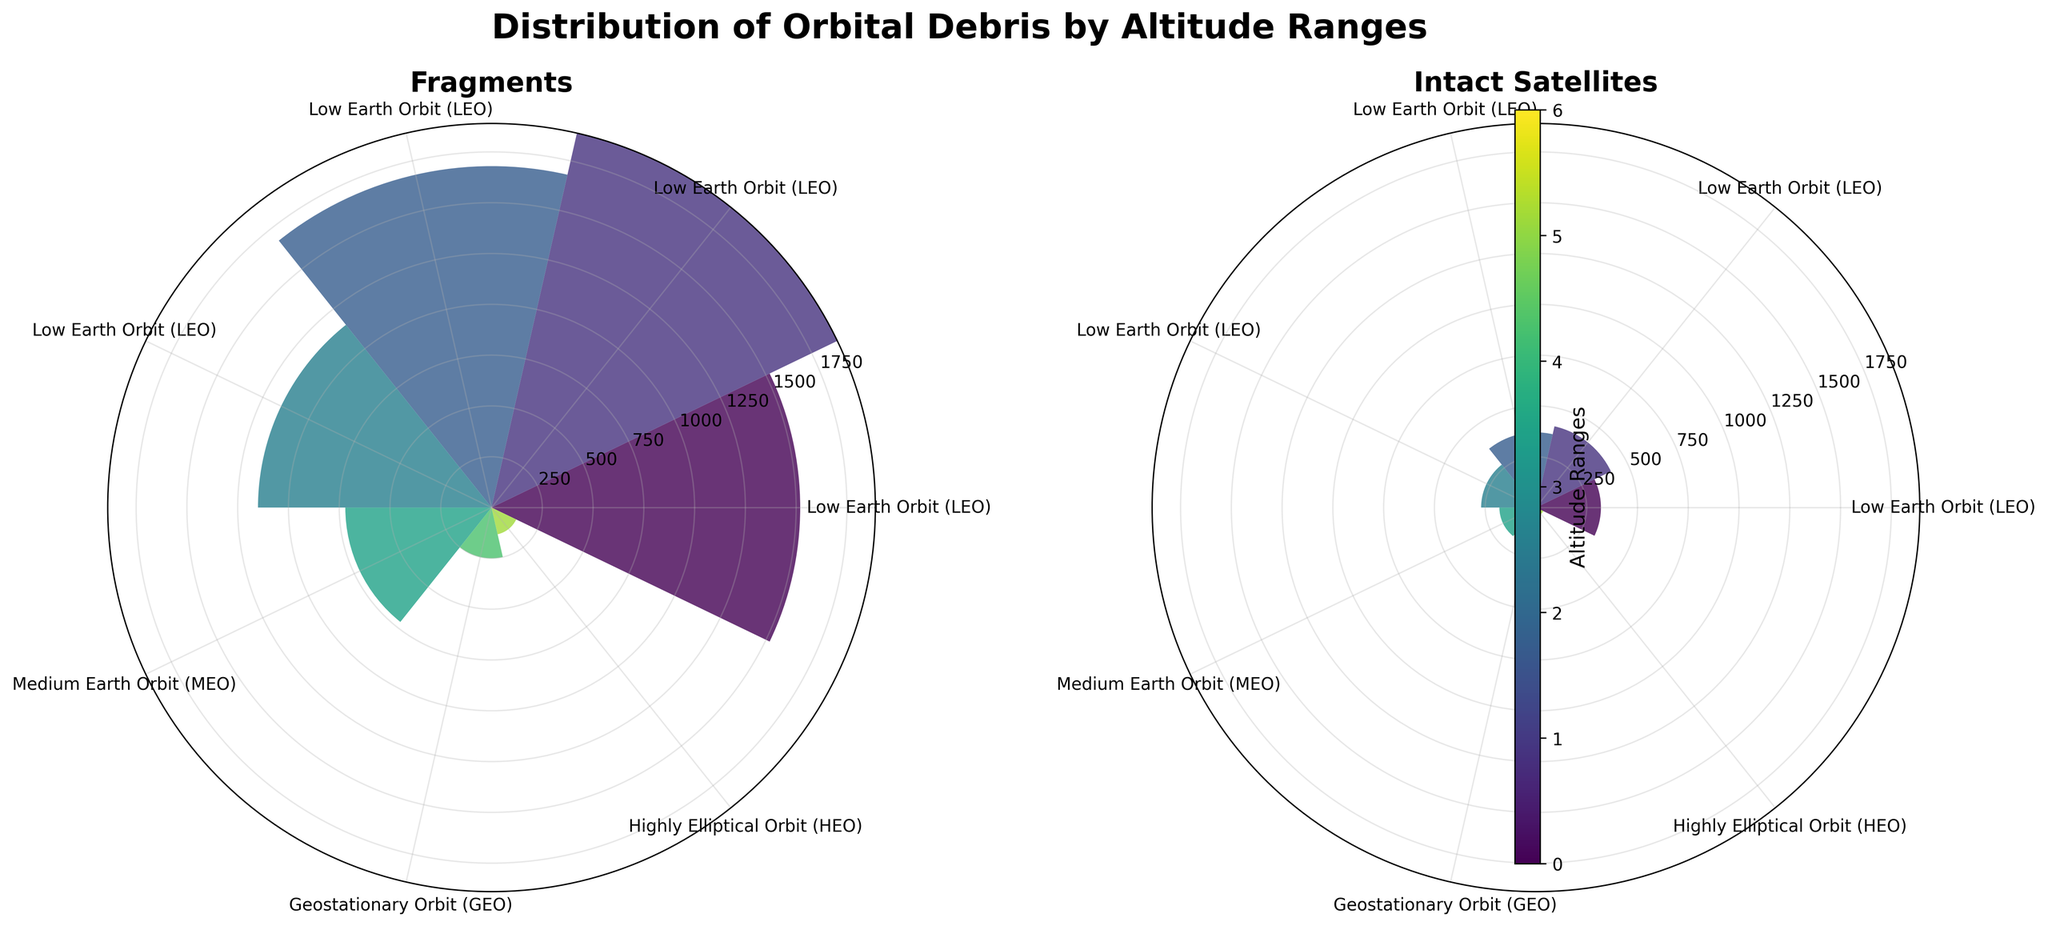How many categories are shown in the figure? Count the distinct categories represented by the bars. There are 7 categories: Low Earth Orbit (LEO) 200-500, Low Earth Orbit (LEO) 500-700, Low Earth Orbit (LEO) 700-900, Low Earth Orbit (LEO) 900-1200, Medium Earth Orbit (MEO) 1200-20000, Geostationary Orbit (GEO) 35786, and Highly Elliptical Orbit (HEO) 200-35786.
Answer: 7 Which altitude range has the highest number of fragments? Look at the bar heights in the Fragments subplot. The bar for Low Earth Orbit (LEO) 500-700 is the tallest, representing 1890 fragments.
Answer: LEO 500-700 What is the total number of intact satellites across all altitude ranges? Sum the values of intact satellites from all categories: 320 + 410 + 370 + 270 + 180 + 65 + 40 = 1655.
Answer: 1655 Which has more intact satellites: Medium Earth Orbit (MEO) or Highly Elliptical Orbit (HEO)? Compare the height of the bars in the Intact Satellites subplot for MEO (180) and HEO (40). MEO has more intact satellites.
Answer: MEO What is the difference in the number of fragments between the Low Earth Orbit (LEO) 900-1200 and the Geostationary Orbit (GEO) 35786? Subtract the number of fragments in GEO from LEO 900-1200: 1150 - 250 = 900.
Answer: 900 Which category has the lowest number of fragments? Look for the shortest bar in the Fragments subplot. Highly Elliptical Orbit (HEO) 200-35786 has the lowest number of fragments with 135.
Answer: HEO 200-35786 What is the average number of fragments in Low Earth Orbit (LEO) across all altitude ranges? Calculate the average of the fragment numbers in LEO: (1520 + 1890 + 1680 + 1150) / 4 = 1560.
Answer: 1560 Which category has a higher count in intact satellites compared to fragments? Compare the Intact Satellites bar heights to the Fragments bar heights for each category. None of the categories have more intact satellites than fragments.
Answer: None How many categories have more than 1000 fragments? Count the bars in the Fragments subplot that are above the 1000 fragment mark. There are three: LEO 200-500, LEO 500-700, and LEO 700-900.
Answer: 3 Which category appears to contribute the least to the total orbital debris (fragments + intact satellites)? Sum up fragments and intact satellites for each category; look for the smallest total. Highly Elliptical Orbit (HEO) 200-35786 has the least with 135 fragments + 40 intact satellites = 175.
Answer: HEO 200-35786 